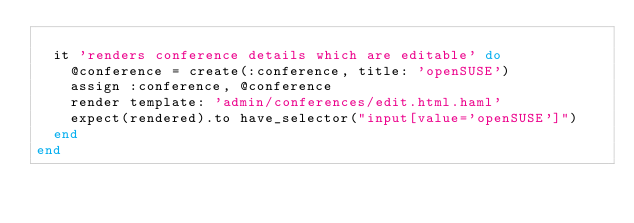<code> <loc_0><loc_0><loc_500><loc_500><_Ruby_>
  it 'renders conference details which are editable' do
    @conference = create(:conference, title: 'openSUSE')
    assign :conference, @conference
    render template: 'admin/conferences/edit.html.haml'
    expect(rendered).to have_selector("input[value='openSUSE']")
  end
end
</code> 